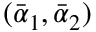Convert formula to latex. <formula><loc_0><loc_0><loc_500><loc_500>( \bar { \alpha } _ { 1 } , \bar { \alpha } _ { 2 } )</formula> 